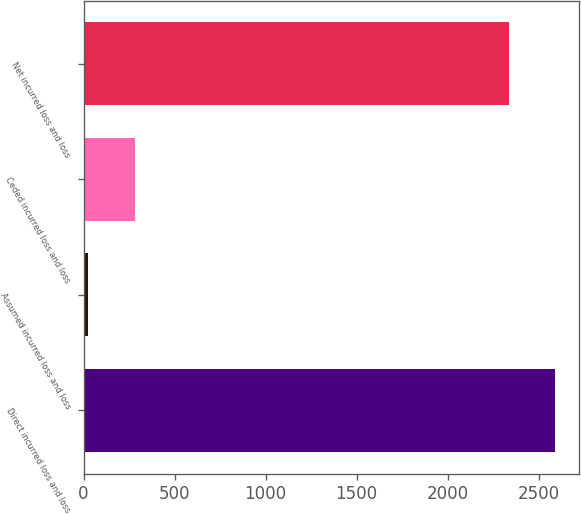Convert chart. <chart><loc_0><loc_0><loc_500><loc_500><bar_chart><fcel>Direct incurred loss and loss<fcel>Assumed incurred loss and loss<fcel>Ceded incurred loss and loss<fcel>Net incurred loss and loss<nl><fcel>2591.4<fcel>24<fcel>280.4<fcel>2335<nl></chart> 